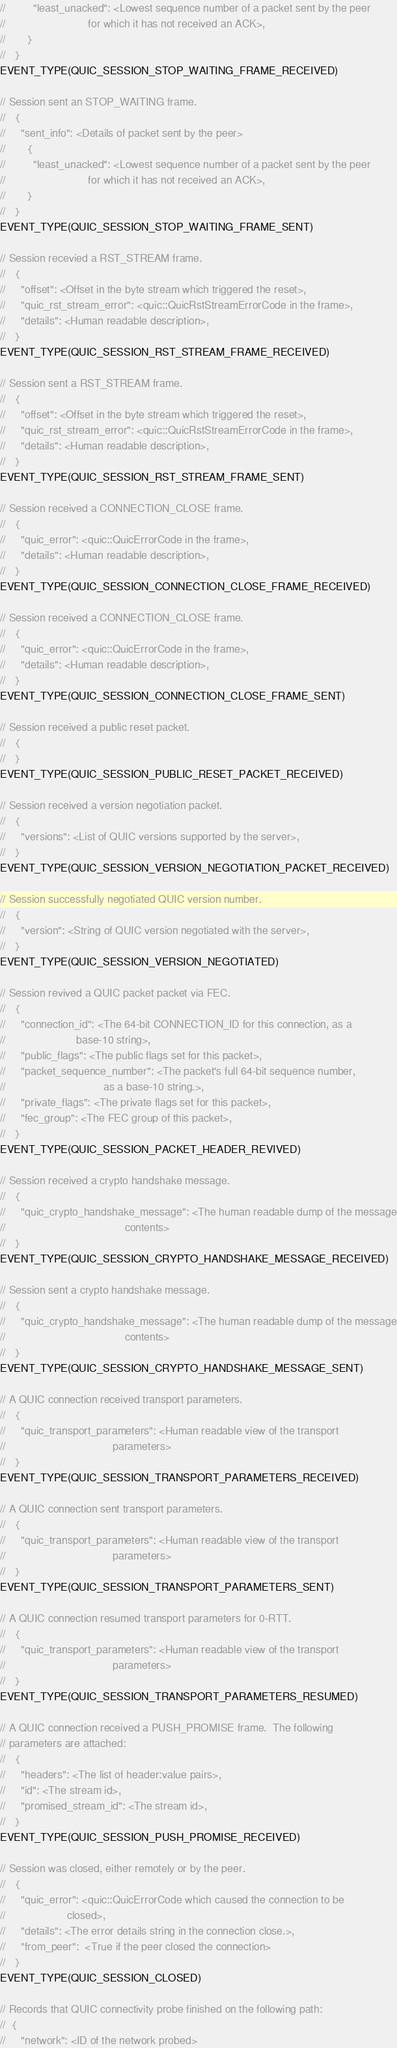<code> <loc_0><loc_0><loc_500><loc_500><_C_>//         "least_unacked": <Lowest sequence number of a packet sent by the peer
//                           for which it has not received an ACK>,
//       }
//   }
EVENT_TYPE(QUIC_SESSION_STOP_WAITING_FRAME_RECEIVED)

// Session sent an STOP_WAITING frame.
//   {
//     "sent_info": <Details of packet sent by the peer>
//       {
//         "least_unacked": <Lowest sequence number of a packet sent by the peer
//                           for which it has not received an ACK>,
//       }
//   }
EVENT_TYPE(QUIC_SESSION_STOP_WAITING_FRAME_SENT)

// Session recevied a RST_STREAM frame.
//   {
//     "offset": <Offset in the byte stream which triggered the reset>,
//     "quic_rst_stream_error": <quic::QuicRstStreamErrorCode in the frame>,
//     "details": <Human readable description>,
//   }
EVENT_TYPE(QUIC_SESSION_RST_STREAM_FRAME_RECEIVED)

// Session sent a RST_STREAM frame.
//   {
//     "offset": <Offset in the byte stream which triggered the reset>,
//     "quic_rst_stream_error": <quic::QuicRstStreamErrorCode in the frame>,
//     "details": <Human readable description>,
//   }
EVENT_TYPE(QUIC_SESSION_RST_STREAM_FRAME_SENT)

// Session received a CONNECTION_CLOSE frame.
//   {
//     "quic_error": <quic::QuicErrorCode in the frame>,
//     "details": <Human readable description>,
//   }
EVENT_TYPE(QUIC_SESSION_CONNECTION_CLOSE_FRAME_RECEIVED)

// Session received a CONNECTION_CLOSE frame.
//   {
//     "quic_error": <quic::QuicErrorCode in the frame>,
//     "details": <Human readable description>,
//   }
EVENT_TYPE(QUIC_SESSION_CONNECTION_CLOSE_FRAME_SENT)

// Session received a public reset packet.
//   {
//   }
EVENT_TYPE(QUIC_SESSION_PUBLIC_RESET_PACKET_RECEIVED)

// Session received a version negotiation packet.
//   {
//     "versions": <List of QUIC versions supported by the server>,
//   }
EVENT_TYPE(QUIC_SESSION_VERSION_NEGOTIATION_PACKET_RECEIVED)

// Session successfully negotiated QUIC version number.
//   {
//     "version": <String of QUIC version negotiated with the server>,
//   }
EVENT_TYPE(QUIC_SESSION_VERSION_NEGOTIATED)

// Session revived a QUIC packet packet via FEC.
//   {
//     "connection_id": <The 64-bit CONNECTION_ID for this connection, as a
//                       base-10 string>,
//     "public_flags": <The public flags set for this packet>,
//     "packet_sequence_number": <The packet's full 64-bit sequence number,
//                                as a base-10 string.>,
//     "private_flags": <The private flags set for this packet>,
//     "fec_group": <The FEC group of this packet>,
//   }
EVENT_TYPE(QUIC_SESSION_PACKET_HEADER_REVIVED)

// Session received a crypto handshake message.
//   {
//     "quic_crypto_handshake_message": <The human readable dump of the message
//                                       contents>
//   }
EVENT_TYPE(QUIC_SESSION_CRYPTO_HANDSHAKE_MESSAGE_RECEIVED)

// Session sent a crypto handshake message.
//   {
//     "quic_crypto_handshake_message": <The human readable dump of the message
//                                       contents>
//   }
EVENT_TYPE(QUIC_SESSION_CRYPTO_HANDSHAKE_MESSAGE_SENT)

// A QUIC connection received transport parameters.
//   {
//     "quic_transport_parameters": <Human readable view of the transport
//                                   parameters>
//   }
EVENT_TYPE(QUIC_SESSION_TRANSPORT_PARAMETERS_RECEIVED)

// A QUIC connection sent transport parameters.
//   {
//     "quic_transport_parameters": <Human readable view of the transport
//                                   parameters>
//   }
EVENT_TYPE(QUIC_SESSION_TRANSPORT_PARAMETERS_SENT)

// A QUIC connection resumed transport parameters for 0-RTT.
//   {
//     "quic_transport_parameters": <Human readable view of the transport
//                                   parameters>
//   }
EVENT_TYPE(QUIC_SESSION_TRANSPORT_PARAMETERS_RESUMED)

// A QUIC connection received a PUSH_PROMISE frame.  The following
// parameters are attached:
//   {
//     "headers": <The list of header:value pairs>,
//     "id": <The stream id>,
//     "promised_stream_id": <The stream id>,
//   }
EVENT_TYPE(QUIC_SESSION_PUSH_PROMISE_RECEIVED)

// Session was closed, either remotely or by the peer.
//   {
//     "quic_error": <quic::QuicErrorCode which caused the connection to be
//                    closed>,
//     "details": <The error details string in the connection close.>,
//     "from_peer":  <True if the peer closed the connection>
//   }
EVENT_TYPE(QUIC_SESSION_CLOSED)

// Records that QUIC connectivity probe finished on the following path:
//  {
//     "network": <ID of the network probed></code> 